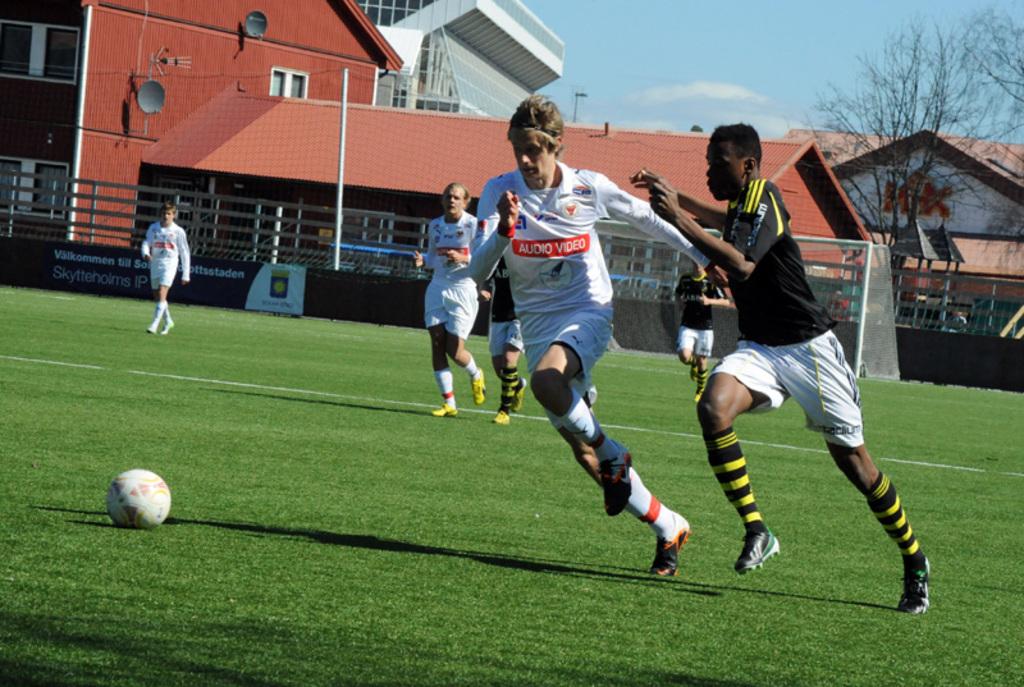What is the sponsor's name in white letters on a red background on the jersey?
Give a very brief answer. Audio video. What sponsor can be seen on the banner?
Offer a very short reply. Skytteholms ip. 